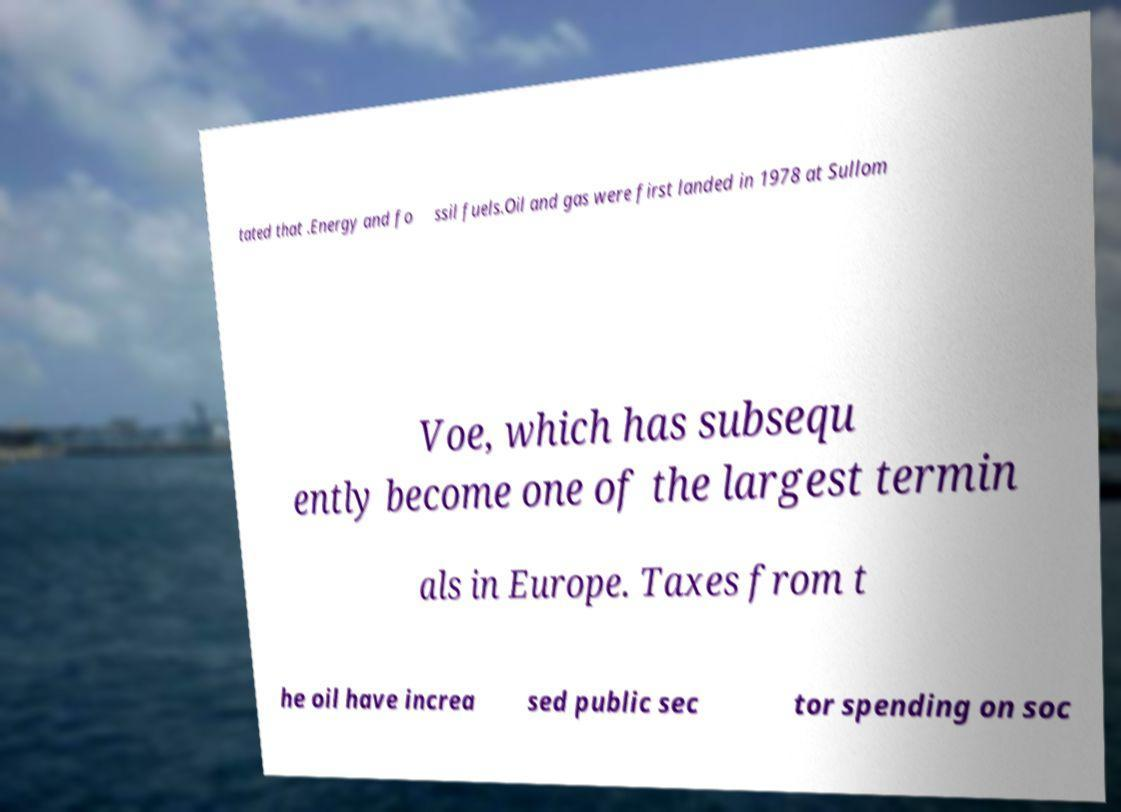Can you accurately transcribe the text from the provided image for me? tated that .Energy and fo ssil fuels.Oil and gas were first landed in 1978 at Sullom Voe, which has subsequ ently become one of the largest termin als in Europe. Taxes from t he oil have increa sed public sec tor spending on soc 